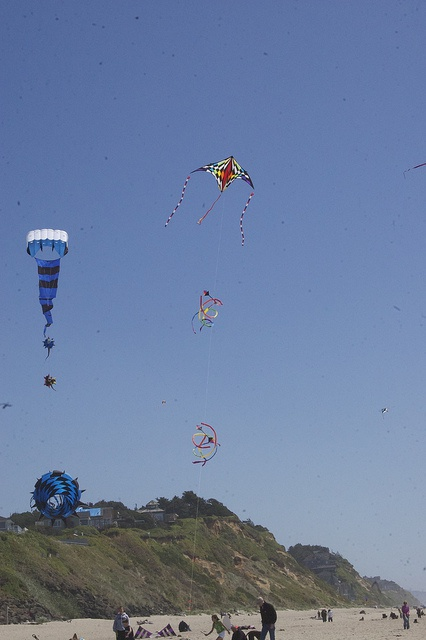Describe the objects in this image and their specific colors. I can see kite in gray, blue, lavender, and black tones, kite in gray, black, navy, blue, and darkblue tones, kite in gray and black tones, kite in gray and darkgray tones, and people in gray, black, and darkgray tones in this image. 